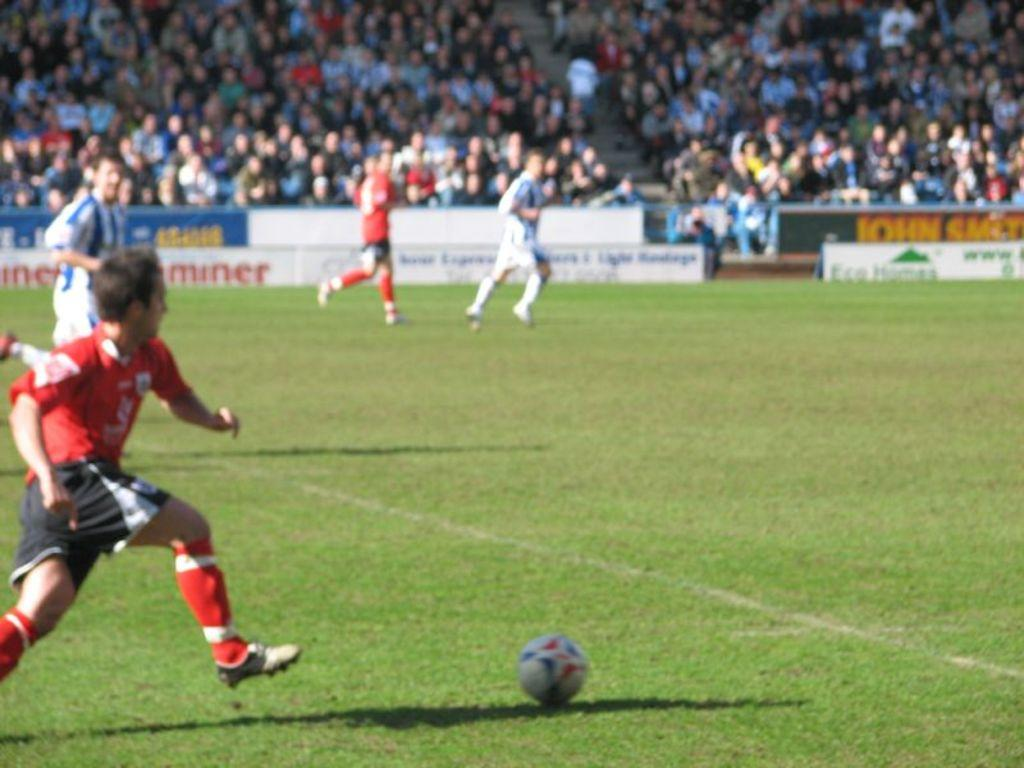<image>
Provide a brief description of the given image. The sign in the background of this football pitch says the name John. 